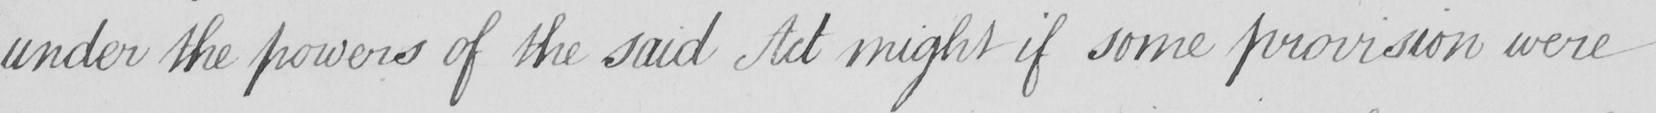What text is written in this handwritten line? under the powers of the said Act might if some provision were 